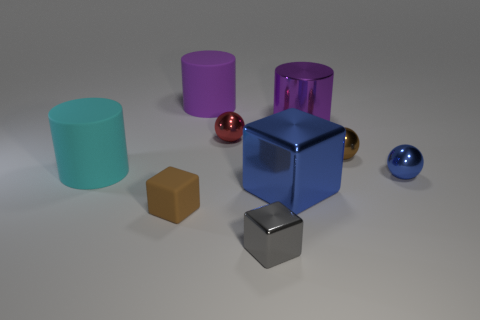Subtract all purple cylinders. How many cylinders are left? 1 Subtract all purple cubes. How many purple cylinders are left? 2 Add 1 big cubes. How many objects exist? 10 Subtract 1 blocks. How many blocks are left? 2 Subtract all spheres. How many objects are left? 6 Add 8 red metal things. How many red metal things are left? 9 Add 7 tiny gray matte cubes. How many tiny gray matte cubes exist? 7 Subtract 0 purple balls. How many objects are left? 9 Subtract all gray spheres. Subtract all red cylinders. How many spheres are left? 3 Subtract all large cylinders. Subtract all tiny red balls. How many objects are left? 5 